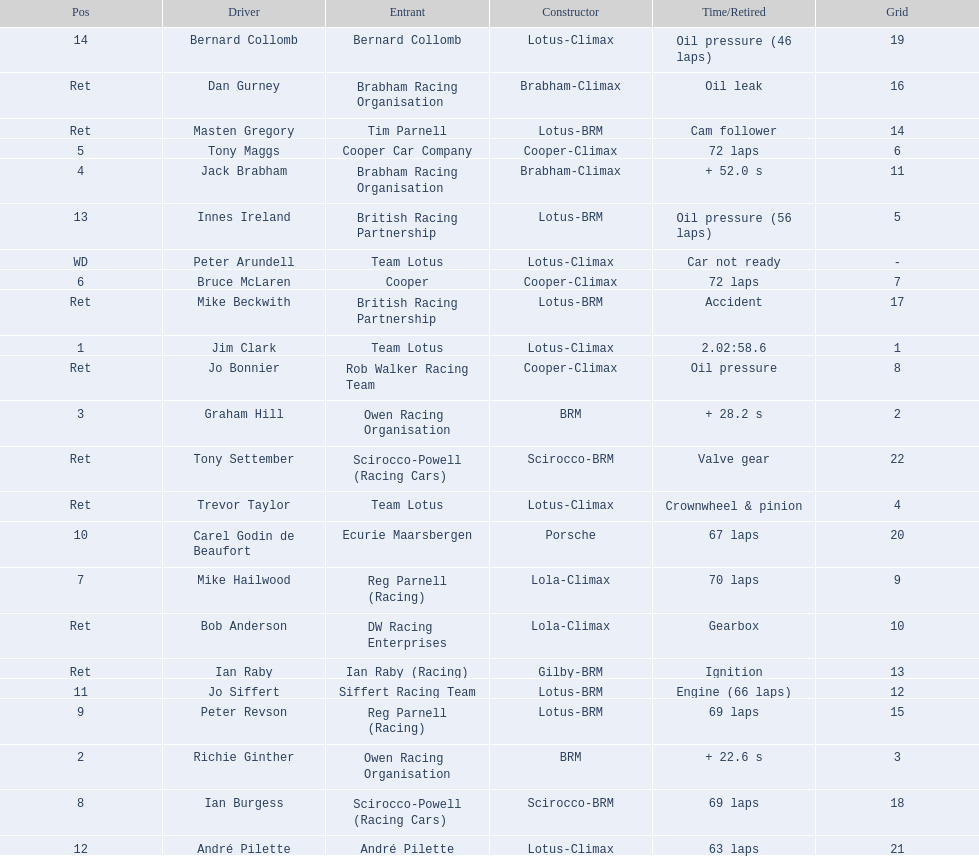Could you help me parse every detail presented in this table? {'header': ['Pos', 'Driver', 'Entrant', 'Constructor', 'Time/Retired', 'Grid'], 'rows': [['14', 'Bernard Collomb', 'Bernard Collomb', 'Lotus-Climax', 'Oil pressure (46 laps)', '19'], ['Ret', 'Dan Gurney', 'Brabham Racing Organisation', 'Brabham-Climax', 'Oil leak', '16'], ['Ret', 'Masten Gregory', 'Tim Parnell', 'Lotus-BRM', 'Cam follower', '14'], ['5', 'Tony Maggs', 'Cooper Car Company', 'Cooper-Climax', '72 laps', '6'], ['4', 'Jack Brabham', 'Brabham Racing Organisation', 'Brabham-Climax', '+ 52.0 s', '11'], ['13', 'Innes Ireland', 'British Racing Partnership', 'Lotus-BRM', 'Oil pressure (56 laps)', '5'], ['WD', 'Peter Arundell', 'Team Lotus', 'Lotus-Climax', 'Car not ready', '-'], ['6', 'Bruce McLaren', 'Cooper', 'Cooper-Climax', '72 laps', '7'], ['Ret', 'Mike Beckwith', 'British Racing Partnership', 'Lotus-BRM', 'Accident', '17'], ['1', 'Jim Clark', 'Team Lotus', 'Lotus-Climax', '2.02:58.6', '1'], ['Ret', 'Jo Bonnier', 'Rob Walker Racing Team', 'Cooper-Climax', 'Oil pressure', '8'], ['3', 'Graham Hill', 'Owen Racing Organisation', 'BRM', '+ 28.2 s', '2'], ['Ret', 'Tony Settember', 'Scirocco-Powell (Racing Cars)', 'Scirocco-BRM', 'Valve gear', '22'], ['Ret', 'Trevor Taylor', 'Team Lotus', 'Lotus-Climax', 'Crownwheel & pinion', '4'], ['10', 'Carel Godin de Beaufort', 'Ecurie Maarsbergen', 'Porsche', '67 laps', '20'], ['7', 'Mike Hailwood', 'Reg Parnell (Racing)', 'Lola-Climax', '70 laps', '9'], ['Ret', 'Bob Anderson', 'DW Racing Enterprises', 'Lola-Climax', 'Gearbox', '10'], ['Ret', 'Ian Raby', 'Ian Raby (Racing)', 'Gilby-BRM', 'Ignition', '13'], ['11', 'Jo Siffert', 'Siffert Racing Team', 'Lotus-BRM', 'Engine (66 laps)', '12'], ['9', 'Peter Revson', 'Reg Parnell (Racing)', 'Lotus-BRM', '69 laps', '15'], ['2', 'Richie Ginther', 'Owen Racing Organisation', 'BRM', '+ 22.6 s', '3'], ['8', 'Ian Burgess', 'Scirocco-Powell (Racing Cars)', 'Scirocco-BRM', '69 laps', '18'], ['12', 'André Pilette', 'André Pilette', 'Lotus-Climax', '63 laps', '21']]} Who are all the drivers? Jim Clark, Richie Ginther, Graham Hill, Jack Brabham, Tony Maggs, Bruce McLaren, Mike Hailwood, Ian Burgess, Peter Revson, Carel Godin de Beaufort, Jo Siffert, André Pilette, Innes Ireland, Bernard Collomb, Ian Raby, Dan Gurney, Mike Beckwith, Masten Gregory, Trevor Taylor, Jo Bonnier, Tony Settember, Bob Anderson, Peter Arundell. What position were they in? 1, 2, 3, 4, 5, 6, 7, 8, 9, 10, 11, 12, 13, 14, Ret, Ret, Ret, Ret, Ret, Ret, Ret, Ret, WD. What about just tony maggs and jo siffert? 5, 11. And between them, which driver came in earlier? Tony Maggs. 